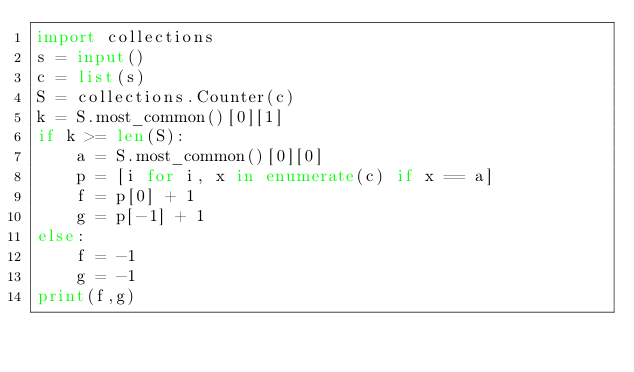<code> <loc_0><loc_0><loc_500><loc_500><_Python_>import collections
s = input()
c = list(s)
S = collections.Counter(c)
k = S.most_common()[0][1]
if k >= len(S):
    a = S.most_common()[0][0]
    p = [i for i, x in enumerate(c) if x == a]
    f = p[0] + 1
    g = p[-1] + 1
else:
    f = -1
    g = -1
print(f,g)</code> 